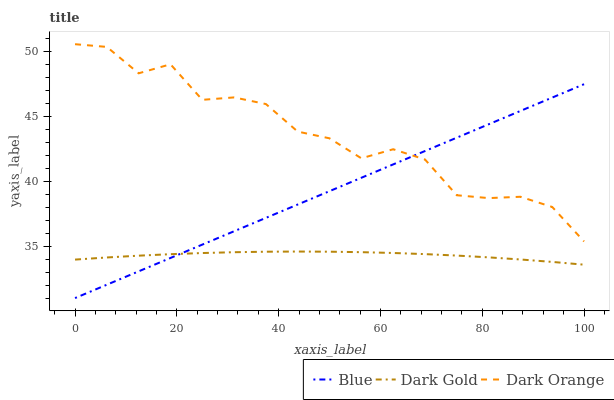Does Dark Gold have the minimum area under the curve?
Answer yes or no. Yes. Does Dark Orange have the maximum area under the curve?
Answer yes or no. Yes. Does Dark Orange have the minimum area under the curve?
Answer yes or no. No. Does Dark Gold have the maximum area under the curve?
Answer yes or no. No. Is Blue the smoothest?
Answer yes or no. Yes. Is Dark Orange the roughest?
Answer yes or no. Yes. Is Dark Gold the smoothest?
Answer yes or no. No. Is Dark Gold the roughest?
Answer yes or no. No. Does Blue have the lowest value?
Answer yes or no. Yes. Does Dark Gold have the lowest value?
Answer yes or no. No. Does Dark Orange have the highest value?
Answer yes or no. Yes. Does Dark Gold have the highest value?
Answer yes or no. No. Is Dark Gold less than Dark Orange?
Answer yes or no. Yes. Is Dark Orange greater than Dark Gold?
Answer yes or no. Yes. Does Blue intersect Dark Gold?
Answer yes or no. Yes. Is Blue less than Dark Gold?
Answer yes or no. No. Is Blue greater than Dark Gold?
Answer yes or no. No. Does Dark Gold intersect Dark Orange?
Answer yes or no. No. 